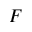<formula> <loc_0><loc_0><loc_500><loc_500>F</formula> 